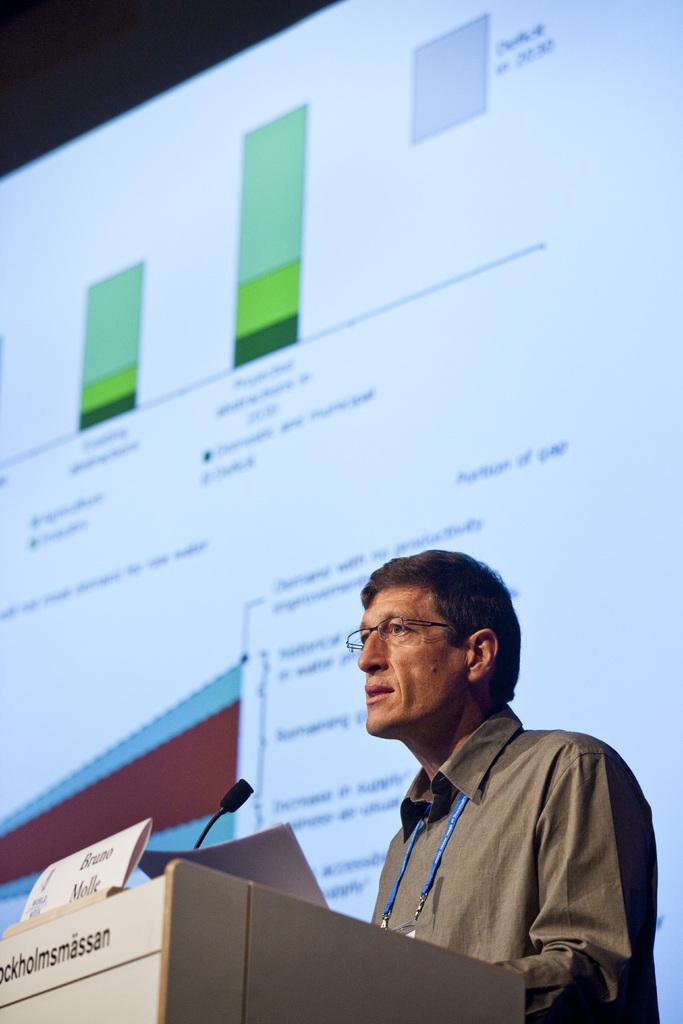Could you give a brief overview of what you see in this image? In this image we can see a man standing at the podium and holding a paper in the hands. In the background there is a display screen. 